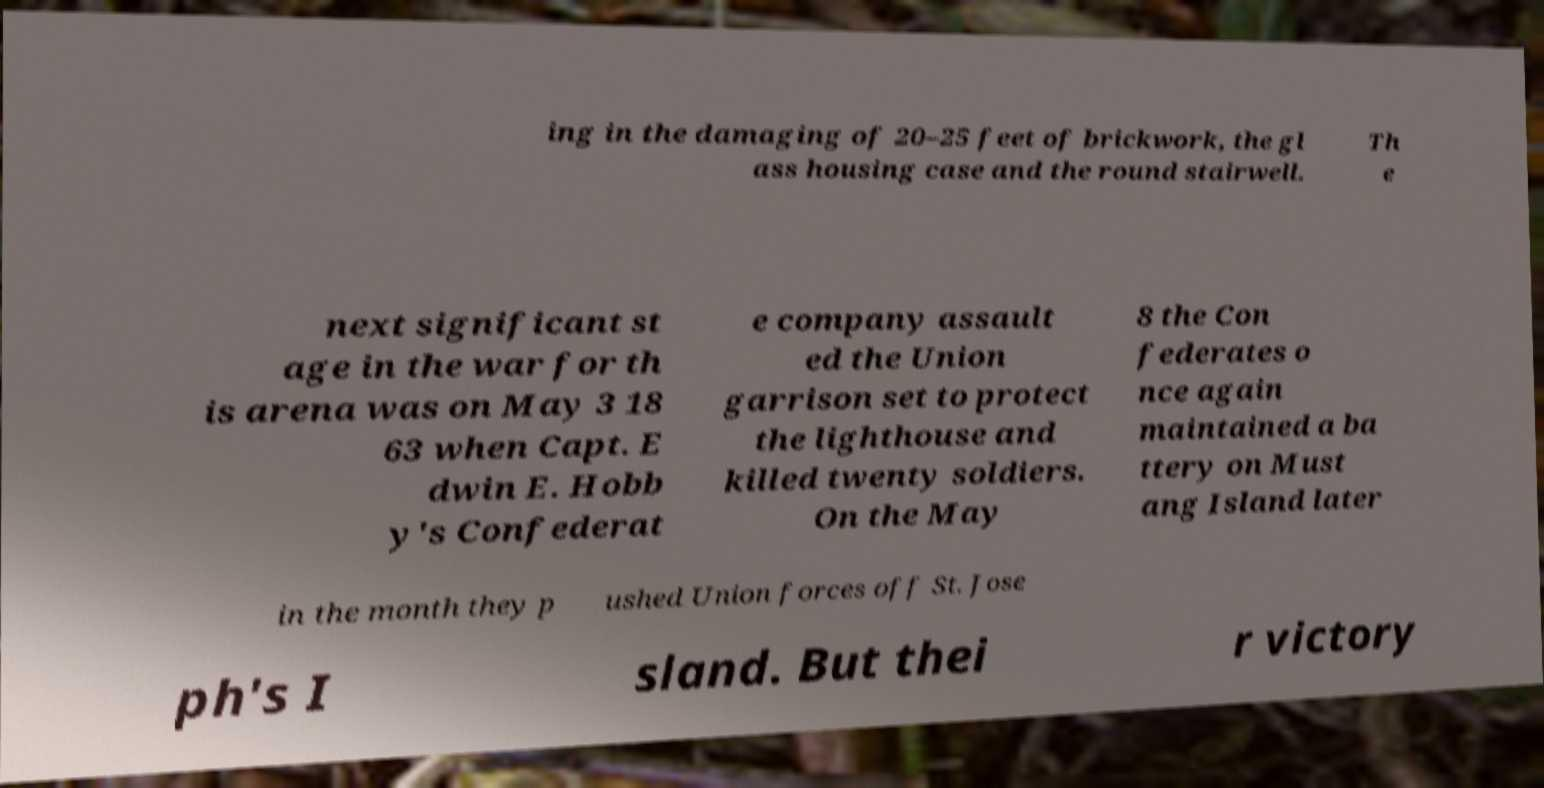What messages or text are displayed in this image? I need them in a readable, typed format. ing in the damaging of 20–25 feet of brickwork, the gl ass housing case and the round stairwell. Th e next significant st age in the war for th is arena was on May 3 18 63 when Capt. E dwin E. Hobb y's Confederat e company assault ed the Union garrison set to protect the lighthouse and killed twenty soldiers. On the May 8 the Con federates o nce again maintained a ba ttery on Must ang Island later in the month they p ushed Union forces off St. Jose ph's I sland. But thei r victory 